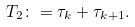<formula> <loc_0><loc_0><loc_500><loc_500>T _ { 2 } \colon = \tau _ { k } + \tau _ { k + 1 } .</formula> 